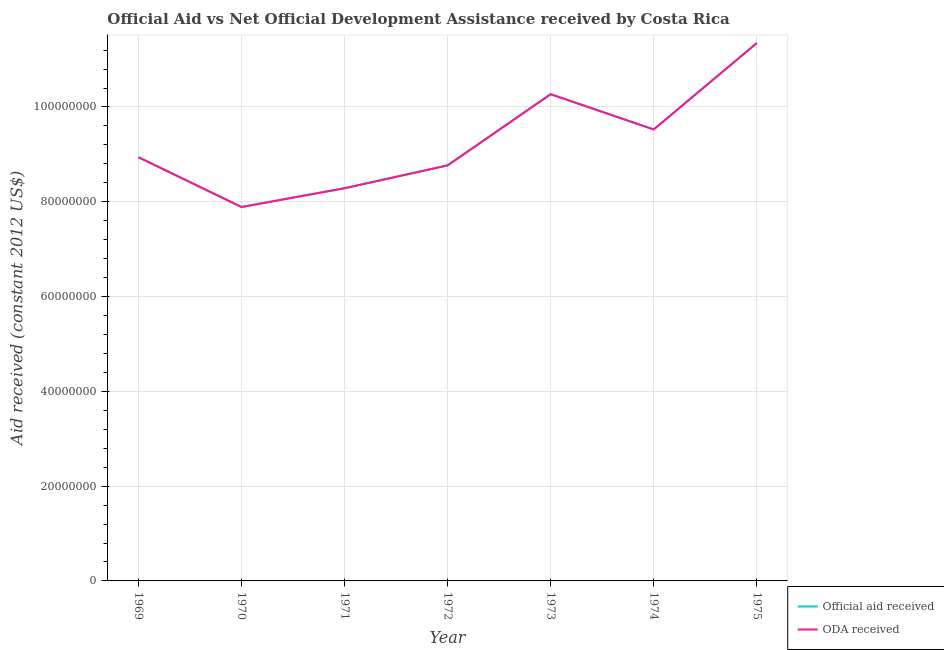Is the number of lines equal to the number of legend labels?
Your answer should be compact. Yes. What is the official aid received in 1974?
Provide a short and direct response. 9.52e+07. Across all years, what is the maximum official aid received?
Provide a succinct answer. 1.13e+08. Across all years, what is the minimum oda received?
Make the answer very short. 7.89e+07. In which year was the official aid received maximum?
Your answer should be very brief. 1975. What is the total oda received in the graph?
Give a very brief answer. 6.50e+08. What is the difference between the official aid received in 1972 and that in 1974?
Provide a succinct answer. -7.58e+06. What is the difference between the oda received in 1971 and the official aid received in 1970?
Provide a succinct answer. 3.96e+06. What is the average official aid received per year?
Give a very brief answer. 9.29e+07. What is the ratio of the oda received in 1973 to that in 1975?
Your response must be concise. 0.9. Is the difference between the official aid received in 1971 and 1972 greater than the difference between the oda received in 1971 and 1972?
Make the answer very short. No. What is the difference between the highest and the second highest official aid received?
Your response must be concise. 1.08e+07. What is the difference between the highest and the lowest oda received?
Your answer should be very brief. 3.46e+07. Is the sum of the oda received in 1969 and 1975 greater than the maximum official aid received across all years?
Ensure brevity in your answer.  Yes. Does the official aid received monotonically increase over the years?
Offer a very short reply. No. Is the oda received strictly greater than the official aid received over the years?
Make the answer very short. No. How many years are there in the graph?
Keep it short and to the point. 7. What is the difference between two consecutive major ticks on the Y-axis?
Give a very brief answer. 2.00e+07. Does the graph contain grids?
Offer a very short reply. Yes. How many legend labels are there?
Give a very brief answer. 2. How are the legend labels stacked?
Give a very brief answer. Vertical. What is the title of the graph?
Ensure brevity in your answer.  Official Aid vs Net Official Development Assistance received by Costa Rica . Does "Short-term debt" appear as one of the legend labels in the graph?
Your answer should be compact. No. What is the label or title of the X-axis?
Ensure brevity in your answer.  Year. What is the label or title of the Y-axis?
Your answer should be very brief. Aid received (constant 2012 US$). What is the Aid received (constant 2012 US$) in Official aid received in 1969?
Keep it short and to the point. 8.94e+07. What is the Aid received (constant 2012 US$) in ODA received in 1969?
Ensure brevity in your answer.  8.94e+07. What is the Aid received (constant 2012 US$) of Official aid received in 1970?
Your response must be concise. 7.89e+07. What is the Aid received (constant 2012 US$) of ODA received in 1970?
Ensure brevity in your answer.  7.89e+07. What is the Aid received (constant 2012 US$) in Official aid received in 1971?
Provide a succinct answer. 8.28e+07. What is the Aid received (constant 2012 US$) of ODA received in 1971?
Your response must be concise. 8.28e+07. What is the Aid received (constant 2012 US$) in Official aid received in 1972?
Offer a terse response. 8.77e+07. What is the Aid received (constant 2012 US$) in ODA received in 1972?
Provide a succinct answer. 8.77e+07. What is the Aid received (constant 2012 US$) of Official aid received in 1973?
Provide a short and direct response. 1.03e+08. What is the Aid received (constant 2012 US$) in ODA received in 1973?
Offer a very short reply. 1.03e+08. What is the Aid received (constant 2012 US$) of Official aid received in 1974?
Offer a terse response. 9.52e+07. What is the Aid received (constant 2012 US$) in ODA received in 1974?
Keep it short and to the point. 9.52e+07. What is the Aid received (constant 2012 US$) in Official aid received in 1975?
Give a very brief answer. 1.13e+08. What is the Aid received (constant 2012 US$) of ODA received in 1975?
Ensure brevity in your answer.  1.13e+08. Across all years, what is the maximum Aid received (constant 2012 US$) of Official aid received?
Make the answer very short. 1.13e+08. Across all years, what is the maximum Aid received (constant 2012 US$) in ODA received?
Your answer should be compact. 1.13e+08. Across all years, what is the minimum Aid received (constant 2012 US$) of Official aid received?
Keep it short and to the point. 7.89e+07. Across all years, what is the minimum Aid received (constant 2012 US$) of ODA received?
Keep it short and to the point. 7.89e+07. What is the total Aid received (constant 2012 US$) in Official aid received in the graph?
Your answer should be very brief. 6.50e+08. What is the total Aid received (constant 2012 US$) of ODA received in the graph?
Ensure brevity in your answer.  6.50e+08. What is the difference between the Aid received (constant 2012 US$) of Official aid received in 1969 and that in 1970?
Give a very brief answer. 1.05e+07. What is the difference between the Aid received (constant 2012 US$) of ODA received in 1969 and that in 1970?
Ensure brevity in your answer.  1.05e+07. What is the difference between the Aid received (constant 2012 US$) of Official aid received in 1969 and that in 1971?
Give a very brief answer. 6.55e+06. What is the difference between the Aid received (constant 2012 US$) in ODA received in 1969 and that in 1971?
Provide a short and direct response. 6.55e+06. What is the difference between the Aid received (constant 2012 US$) in Official aid received in 1969 and that in 1972?
Give a very brief answer. 1.73e+06. What is the difference between the Aid received (constant 2012 US$) of ODA received in 1969 and that in 1972?
Give a very brief answer. 1.73e+06. What is the difference between the Aid received (constant 2012 US$) of Official aid received in 1969 and that in 1973?
Make the answer very short. -1.33e+07. What is the difference between the Aid received (constant 2012 US$) of ODA received in 1969 and that in 1973?
Give a very brief answer. -1.33e+07. What is the difference between the Aid received (constant 2012 US$) in Official aid received in 1969 and that in 1974?
Keep it short and to the point. -5.85e+06. What is the difference between the Aid received (constant 2012 US$) of ODA received in 1969 and that in 1974?
Offer a very short reply. -5.85e+06. What is the difference between the Aid received (constant 2012 US$) in Official aid received in 1969 and that in 1975?
Your response must be concise. -2.41e+07. What is the difference between the Aid received (constant 2012 US$) of ODA received in 1969 and that in 1975?
Provide a succinct answer. -2.41e+07. What is the difference between the Aid received (constant 2012 US$) in Official aid received in 1970 and that in 1971?
Your answer should be compact. -3.96e+06. What is the difference between the Aid received (constant 2012 US$) of ODA received in 1970 and that in 1971?
Ensure brevity in your answer.  -3.96e+06. What is the difference between the Aid received (constant 2012 US$) in Official aid received in 1970 and that in 1972?
Make the answer very short. -8.78e+06. What is the difference between the Aid received (constant 2012 US$) in ODA received in 1970 and that in 1972?
Provide a short and direct response. -8.78e+06. What is the difference between the Aid received (constant 2012 US$) in Official aid received in 1970 and that in 1973?
Offer a very short reply. -2.38e+07. What is the difference between the Aid received (constant 2012 US$) of ODA received in 1970 and that in 1973?
Your answer should be compact. -2.38e+07. What is the difference between the Aid received (constant 2012 US$) of Official aid received in 1970 and that in 1974?
Keep it short and to the point. -1.64e+07. What is the difference between the Aid received (constant 2012 US$) in ODA received in 1970 and that in 1974?
Provide a short and direct response. -1.64e+07. What is the difference between the Aid received (constant 2012 US$) in Official aid received in 1970 and that in 1975?
Provide a succinct answer. -3.46e+07. What is the difference between the Aid received (constant 2012 US$) of ODA received in 1970 and that in 1975?
Your response must be concise. -3.46e+07. What is the difference between the Aid received (constant 2012 US$) of Official aid received in 1971 and that in 1972?
Ensure brevity in your answer.  -4.82e+06. What is the difference between the Aid received (constant 2012 US$) of ODA received in 1971 and that in 1972?
Make the answer very short. -4.82e+06. What is the difference between the Aid received (constant 2012 US$) of Official aid received in 1971 and that in 1973?
Provide a succinct answer. -1.98e+07. What is the difference between the Aid received (constant 2012 US$) of ODA received in 1971 and that in 1973?
Give a very brief answer. -1.98e+07. What is the difference between the Aid received (constant 2012 US$) of Official aid received in 1971 and that in 1974?
Give a very brief answer. -1.24e+07. What is the difference between the Aid received (constant 2012 US$) of ODA received in 1971 and that in 1974?
Your answer should be very brief. -1.24e+07. What is the difference between the Aid received (constant 2012 US$) in Official aid received in 1971 and that in 1975?
Your answer should be very brief. -3.06e+07. What is the difference between the Aid received (constant 2012 US$) of ODA received in 1971 and that in 1975?
Give a very brief answer. -3.06e+07. What is the difference between the Aid received (constant 2012 US$) in Official aid received in 1972 and that in 1973?
Your response must be concise. -1.50e+07. What is the difference between the Aid received (constant 2012 US$) of ODA received in 1972 and that in 1973?
Make the answer very short. -1.50e+07. What is the difference between the Aid received (constant 2012 US$) in Official aid received in 1972 and that in 1974?
Provide a short and direct response. -7.58e+06. What is the difference between the Aid received (constant 2012 US$) of ODA received in 1972 and that in 1974?
Your response must be concise. -7.58e+06. What is the difference between the Aid received (constant 2012 US$) of Official aid received in 1972 and that in 1975?
Offer a terse response. -2.58e+07. What is the difference between the Aid received (constant 2012 US$) in ODA received in 1972 and that in 1975?
Keep it short and to the point. -2.58e+07. What is the difference between the Aid received (constant 2012 US$) of Official aid received in 1973 and that in 1974?
Your answer should be compact. 7.44e+06. What is the difference between the Aid received (constant 2012 US$) in ODA received in 1973 and that in 1974?
Give a very brief answer. 7.44e+06. What is the difference between the Aid received (constant 2012 US$) in Official aid received in 1973 and that in 1975?
Provide a succinct answer. -1.08e+07. What is the difference between the Aid received (constant 2012 US$) in ODA received in 1973 and that in 1975?
Provide a succinct answer. -1.08e+07. What is the difference between the Aid received (constant 2012 US$) of Official aid received in 1974 and that in 1975?
Offer a terse response. -1.82e+07. What is the difference between the Aid received (constant 2012 US$) of ODA received in 1974 and that in 1975?
Ensure brevity in your answer.  -1.82e+07. What is the difference between the Aid received (constant 2012 US$) of Official aid received in 1969 and the Aid received (constant 2012 US$) of ODA received in 1970?
Provide a succinct answer. 1.05e+07. What is the difference between the Aid received (constant 2012 US$) of Official aid received in 1969 and the Aid received (constant 2012 US$) of ODA received in 1971?
Give a very brief answer. 6.55e+06. What is the difference between the Aid received (constant 2012 US$) in Official aid received in 1969 and the Aid received (constant 2012 US$) in ODA received in 1972?
Your answer should be compact. 1.73e+06. What is the difference between the Aid received (constant 2012 US$) of Official aid received in 1969 and the Aid received (constant 2012 US$) of ODA received in 1973?
Your answer should be compact. -1.33e+07. What is the difference between the Aid received (constant 2012 US$) in Official aid received in 1969 and the Aid received (constant 2012 US$) in ODA received in 1974?
Give a very brief answer. -5.85e+06. What is the difference between the Aid received (constant 2012 US$) of Official aid received in 1969 and the Aid received (constant 2012 US$) of ODA received in 1975?
Offer a very short reply. -2.41e+07. What is the difference between the Aid received (constant 2012 US$) of Official aid received in 1970 and the Aid received (constant 2012 US$) of ODA received in 1971?
Ensure brevity in your answer.  -3.96e+06. What is the difference between the Aid received (constant 2012 US$) of Official aid received in 1970 and the Aid received (constant 2012 US$) of ODA received in 1972?
Give a very brief answer. -8.78e+06. What is the difference between the Aid received (constant 2012 US$) in Official aid received in 1970 and the Aid received (constant 2012 US$) in ODA received in 1973?
Offer a very short reply. -2.38e+07. What is the difference between the Aid received (constant 2012 US$) in Official aid received in 1970 and the Aid received (constant 2012 US$) in ODA received in 1974?
Provide a short and direct response. -1.64e+07. What is the difference between the Aid received (constant 2012 US$) of Official aid received in 1970 and the Aid received (constant 2012 US$) of ODA received in 1975?
Offer a terse response. -3.46e+07. What is the difference between the Aid received (constant 2012 US$) of Official aid received in 1971 and the Aid received (constant 2012 US$) of ODA received in 1972?
Ensure brevity in your answer.  -4.82e+06. What is the difference between the Aid received (constant 2012 US$) in Official aid received in 1971 and the Aid received (constant 2012 US$) in ODA received in 1973?
Provide a succinct answer. -1.98e+07. What is the difference between the Aid received (constant 2012 US$) of Official aid received in 1971 and the Aid received (constant 2012 US$) of ODA received in 1974?
Give a very brief answer. -1.24e+07. What is the difference between the Aid received (constant 2012 US$) of Official aid received in 1971 and the Aid received (constant 2012 US$) of ODA received in 1975?
Provide a short and direct response. -3.06e+07. What is the difference between the Aid received (constant 2012 US$) in Official aid received in 1972 and the Aid received (constant 2012 US$) in ODA received in 1973?
Offer a very short reply. -1.50e+07. What is the difference between the Aid received (constant 2012 US$) of Official aid received in 1972 and the Aid received (constant 2012 US$) of ODA received in 1974?
Your response must be concise. -7.58e+06. What is the difference between the Aid received (constant 2012 US$) in Official aid received in 1972 and the Aid received (constant 2012 US$) in ODA received in 1975?
Your response must be concise. -2.58e+07. What is the difference between the Aid received (constant 2012 US$) of Official aid received in 1973 and the Aid received (constant 2012 US$) of ODA received in 1974?
Your answer should be compact. 7.44e+06. What is the difference between the Aid received (constant 2012 US$) of Official aid received in 1973 and the Aid received (constant 2012 US$) of ODA received in 1975?
Offer a terse response. -1.08e+07. What is the difference between the Aid received (constant 2012 US$) in Official aid received in 1974 and the Aid received (constant 2012 US$) in ODA received in 1975?
Offer a terse response. -1.82e+07. What is the average Aid received (constant 2012 US$) of Official aid received per year?
Your response must be concise. 9.29e+07. What is the average Aid received (constant 2012 US$) in ODA received per year?
Provide a short and direct response. 9.29e+07. In the year 1970, what is the difference between the Aid received (constant 2012 US$) in Official aid received and Aid received (constant 2012 US$) in ODA received?
Make the answer very short. 0. In the year 1972, what is the difference between the Aid received (constant 2012 US$) in Official aid received and Aid received (constant 2012 US$) in ODA received?
Make the answer very short. 0. In the year 1973, what is the difference between the Aid received (constant 2012 US$) of Official aid received and Aid received (constant 2012 US$) of ODA received?
Make the answer very short. 0. In the year 1974, what is the difference between the Aid received (constant 2012 US$) in Official aid received and Aid received (constant 2012 US$) in ODA received?
Make the answer very short. 0. In the year 1975, what is the difference between the Aid received (constant 2012 US$) in Official aid received and Aid received (constant 2012 US$) in ODA received?
Ensure brevity in your answer.  0. What is the ratio of the Aid received (constant 2012 US$) in Official aid received in 1969 to that in 1970?
Make the answer very short. 1.13. What is the ratio of the Aid received (constant 2012 US$) in ODA received in 1969 to that in 1970?
Give a very brief answer. 1.13. What is the ratio of the Aid received (constant 2012 US$) in Official aid received in 1969 to that in 1971?
Your answer should be compact. 1.08. What is the ratio of the Aid received (constant 2012 US$) of ODA received in 1969 to that in 1971?
Provide a short and direct response. 1.08. What is the ratio of the Aid received (constant 2012 US$) of Official aid received in 1969 to that in 1972?
Keep it short and to the point. 1.02. What is the ratio of the Aid received (constant 2012 US$) of ODA received in 1969 to that in 1972?
Keep it short and to the point. 1.02. What is the ratio of the Aid received (constant 2012 US$) in Official aid received in 1969 to that in 1973?
Offer a terse response. 0.87. What is the ratio of the Aid received (constant 2012 US$) in ODA received in 1969 to that in 1973?
Give a very brief answer. 0.87. What is the ratio of the Aid received (constant 2012 US$) of Official aid received in 1969 to that in 1974?
Offer a terse response. 0.94. What is the ratio of the Aid received (constant 2012 US$) in ODA received in 1969 to that in 1974?
Your answer should be very brief. 0.94. What is the ratio of the Aid received (constant 2012 US$) of Official aid received in 1969 to that in 1975?
Keep it short and to the point. 0.79. What is the ratio of the Aid received (constant 2012 US$) in ODA received in 1969 to that in 1975?
Provide a succinct answer. 0.79. What is the ratio of the Aid received (constant 2012 US$) in Official aid received in 1970 to that in 1971?
Your answer should be very brief. 0.95. What is the ratio of the Aid received (constant 2012 US$) in ODA received in 1970 to that in 1971?
Your response must be concise. 0.95. What is the ratio of the Aid received (constant 2012 US$) in Official aid received in 1970 to that in 1972?
Your answer should be very brief. 0.9. What is the ratio of the Aid received (constant 2012 US$) in ODA received in 1970 to that in 1972?
Offer a very short reply. 0.9. What is the ratio of the Aid received (constant 2012 US$) of Official aid received in 1970 to that in 1973?
Your answer should be very brief. 0.77. What is the ratio of the Aid received (constant 2012 US$) of ODA received in 1970 to that in 1973?
Provide a short and direct response. 0.77. What is the ratio of the Aid received (constant 2012 US$) in Official aid received in 1970 to that in 1974?
Offer a very short reply. 0.83. What is the ratio of the Aid received (constant 2012 US$) of ODA received in 1970 to that in 1974?
Offer a terse response. 0.83. What is the ratio of the Aid received (constant 2012 US$) of Official aid received in 1970 to that in 1975?
Make the answer very short. 0.7. What is the ratio of the Aid received (constant 2012 US$) in ODA received in 1970 to that in 1975?
Provide a succinct answer. 0.7. What is the ratio of the Aid received (constant 2012 US$) of Official aid received in 1971 to that in 1972?
Provide a short and direct response. 0.94. What is the ratio of the Aid received (constant 2012 US$) in ODA received in 1971 to that in 1972?
Your answer should be very brief. 0.94. What is the ratio of the Aid received (constant 2012 US$) of Official aid received in 1971 to that in 1973?
Ensure brevity in your answer.  0.81. What is the ratio of the Aid received (constant 2012 US$) of ODA received in 1971 to that in 1973?
Ensure brevity in your answer.  0.81. What is the ratio of the Aid received (constant 2012 US$) of Official aid received in 1971 to that in 1974?
Provide a succinct answer. 0.87. What is the ratio of the Aid received (constant 2012 US$) of ODA received in 1971 to that in 1974?
Your answer should be very brief. 0.87. What is the ratio of the Aid received (constant 2012 US$) of Official aid received in 1971 to that in 1975?
Your answer should be very brief. 0.73. What is the ratio of the Aid received (constant 2012 US$) in ODA received in 1971 to that in 1975?
Offer a terse response. 0.73. What is the ratio of the Aid received (constant 2012 US$) in Official aid received in 1972 to that in 1973?
Your response must be concise. 0.85. What is the ratio of the Aid received (constant 2012 US$) of ODA received in 1972 to that in 1973?
Your answer should be compact. 0.85. What is the ratio of the Aid received (constant 2012 US$) of Official aid received in 1972 to that in 1974?
Give a very brief answer. 0.92. What is the ratio of the Aid received (constant 2012 US$) in ODA received in 1972 to that in 1974?
Ensure brevity in your answer.  0.92. What is the ratio of the Aid received (constant 2012 US$) of Official aid received in 1972 to that in 1975?
Your answer should be very brief. 0.77. What is the ratio of the Aid received (constant 2012 US$) in ODA received in 1972 to that in 1975?
Provide a short and direct response. 0.77. What is the ratio of the Aid received (constant 2012 US$) in Official aid received in 1973 to that in 1974?
Make the answer very short. 1.08. What is the ratio of the Aid received (constant 2012 US$) of ODA received in 1973 to that in 1974?
Provide a short and direct response. 1.08. What is the ratio of the Aid received (constant 2012 US$) of Official aid received in 1973 to that in 1975?
Provide a short and direct response. 0.9. What is the ratio of the Aid received (constant 2012 US$) of ODA received in 1973 to that in 1975?
Provide a succinct answer. 0.9. What is the ratio of the Aid received (constant 2012 US$) of Official aid received in 1974 to that in 1975?
Offer a very short reply. 0.84. What is the ratio of the Aid received (constant 2012 US$) in ODA received in 1974 to that in 1975?
Offer a terse response. 0.84. What is the difference between the highest and the second highest Aid received (constant 2012 US$) of Official aid received?
Your answer should be compact. 1.08e+07. What is the difference between the highest and the second highest Aid received (constant 2012 US$) in ODA received?
Your answer should be very brief. 1.08e+07. What is the difference between the highest and the lowest Aid received (constant 2012 US$) in Official aid received?
Keep it short and to the point. 3.46e+07. What is the difference between the highest and the lowest Aid received (constant 2012 US$) of ODA received?
Provide a short and direct response. 3.46e+07. 